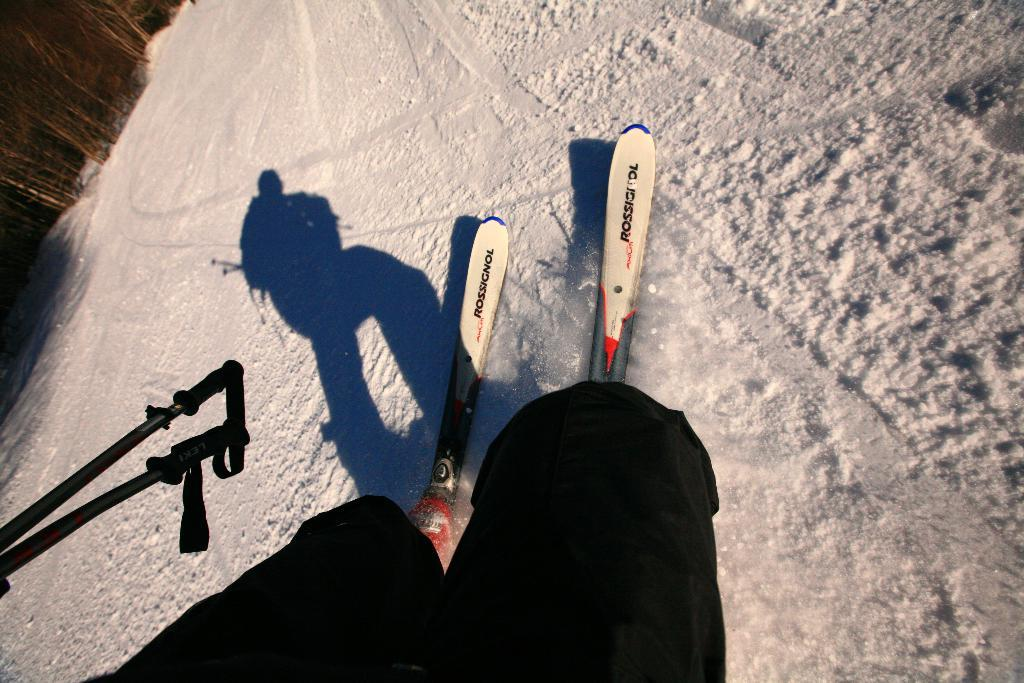What can be seen at the bottom of the image? There are legs of a person visible at the bottom of the image. What objects are present in the image related to a sport or activity? There are two skateboards and sticks visible in the image. What is the weather or season suggested by the image? There is snow visible in the image, suggesting a winter scene. What type of vegetation is present in the image? There are many trees in the top left-hand corner of the image. What type of leather is visible on the person's glove in the image? There is no glove visible in the image, and therefore no leather can be observed. 